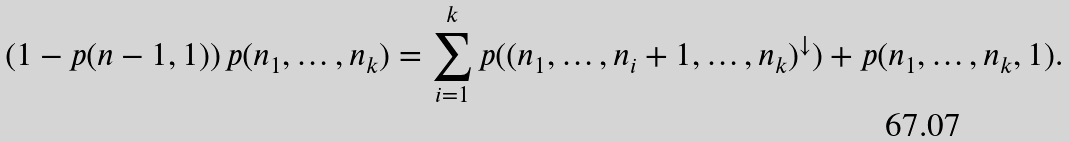<formula> <loc_0><loc_0><loc_500><loc_500>\left ( 1 - p ( n - 1 , 1 ) \right ) p ( n _ { 1 } , \dots , n _ { k } ) = \sum _ { i = 1 } ^ { k } p ( ( n _ { 1 } , \dots , n _ { i } + 1 , \dots , n _ { k } ) ^ { \downarrow } ) + p ( n _ { 1 } , \dots , n _ { k } , 1 ) .</formula> 